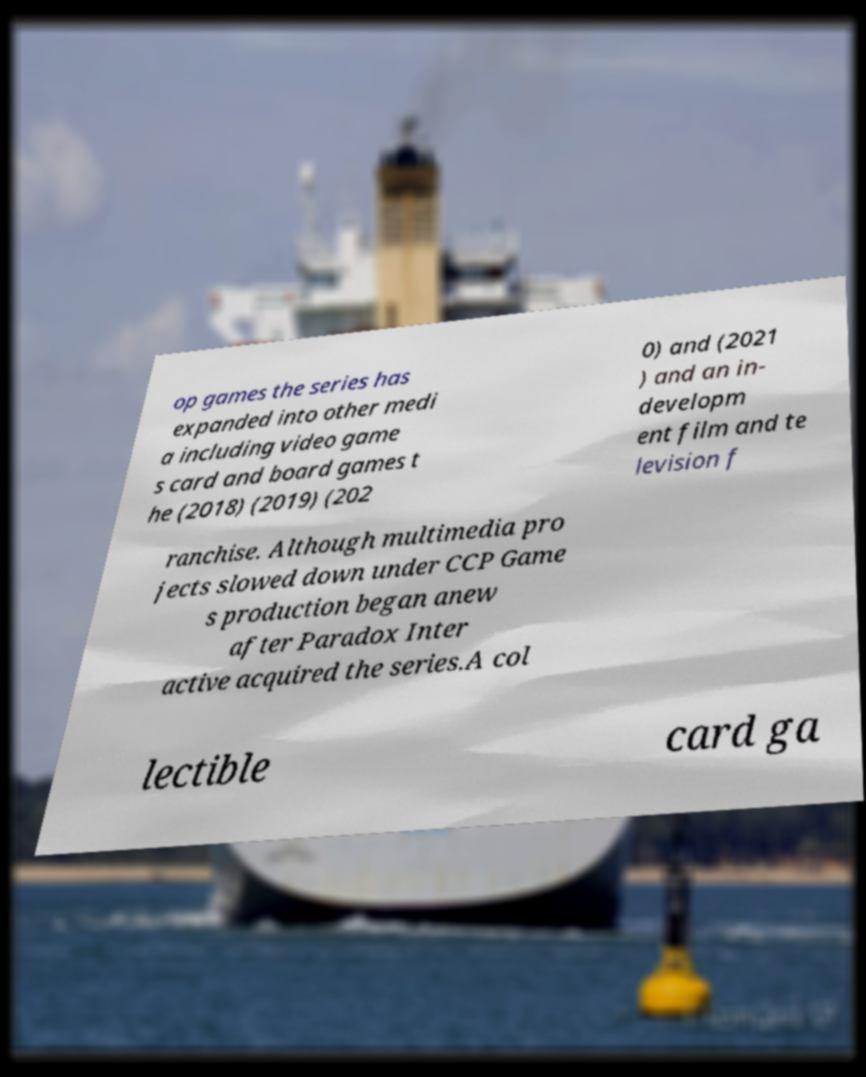Please read and relay the text visible in this image. What does it say? op games the series has expanded into other medi a including video game s card and board games t he (2018) (2019) (202 0) and (2021 ) and an in- developm ent film and te levision f ranchise. Although multimedia pro jects slowed down under CCP Game s production began anew after Paradox Inter active acquired the series.A col lectible card ga 